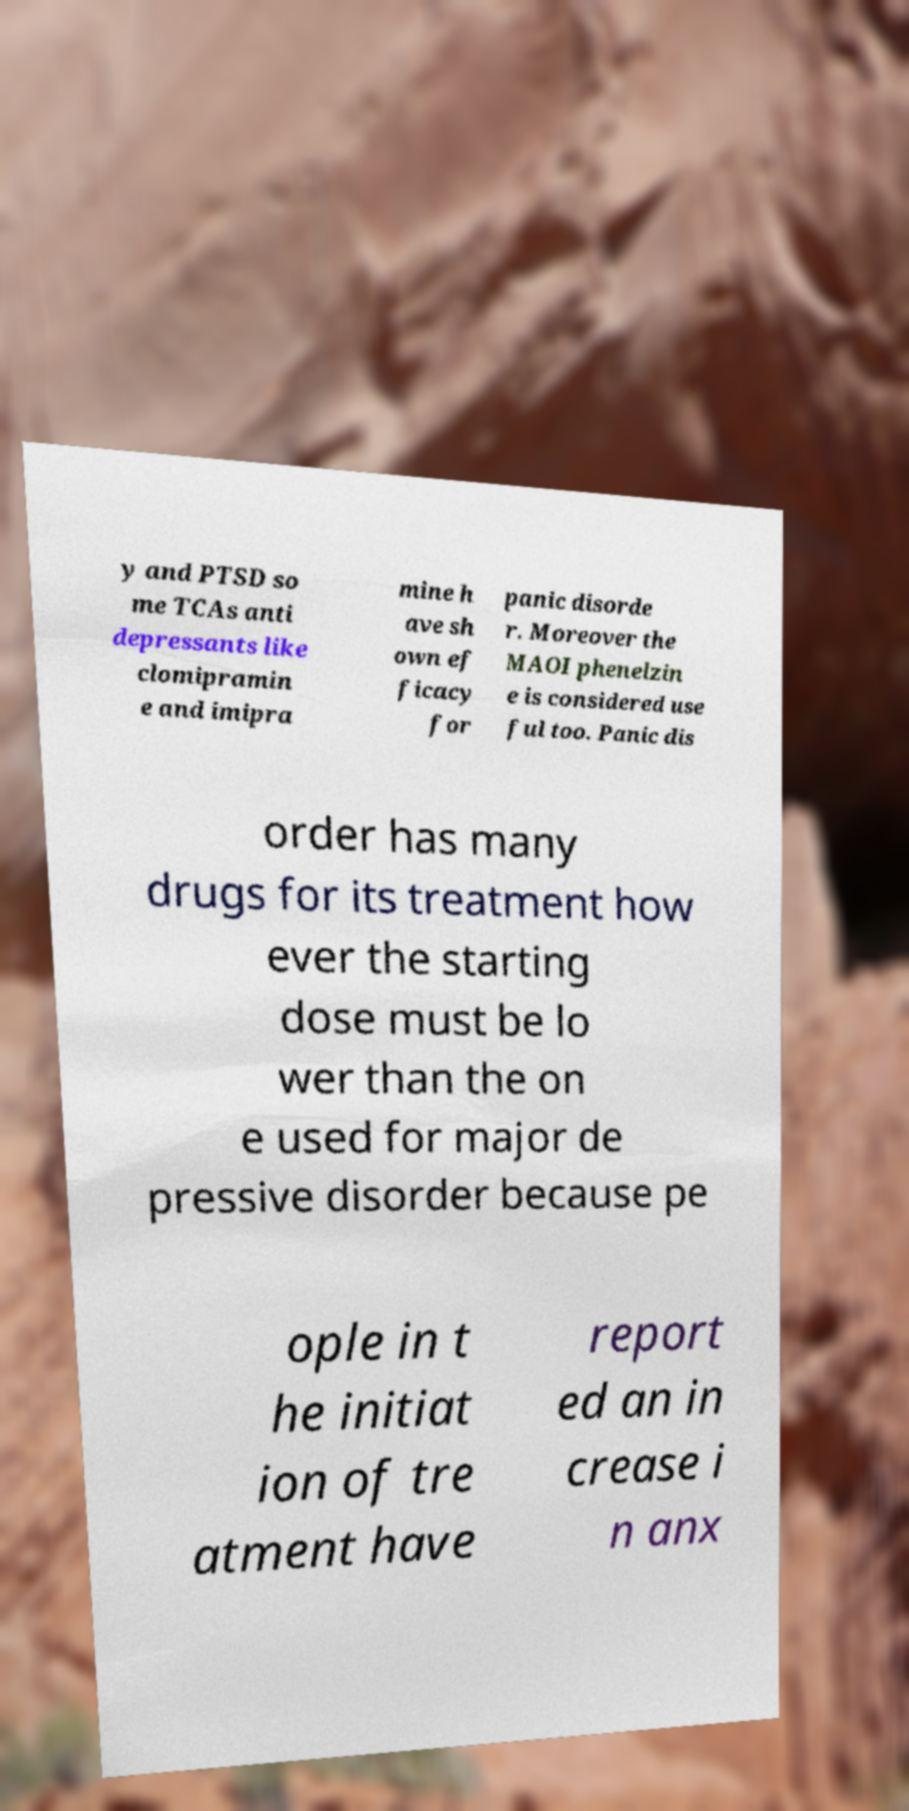Can you read and provide the text displayed in the image?This photo seems to have some interesting text. Can you extract and type it out for me? y and PTSD so me TCAs anti depressants like clomipramin e and imipra mine h ave sh own ef ficacy for panic disorde r. Moreover the MAOI phenelzin e is considered use ful too. Panic dis order has many drugs for its treatment how ever the starting dose must be lo wer than the on e used for major de pressive disorder because pe ople in t he initiat ion of tre atment have report ed an in crease i n anx 